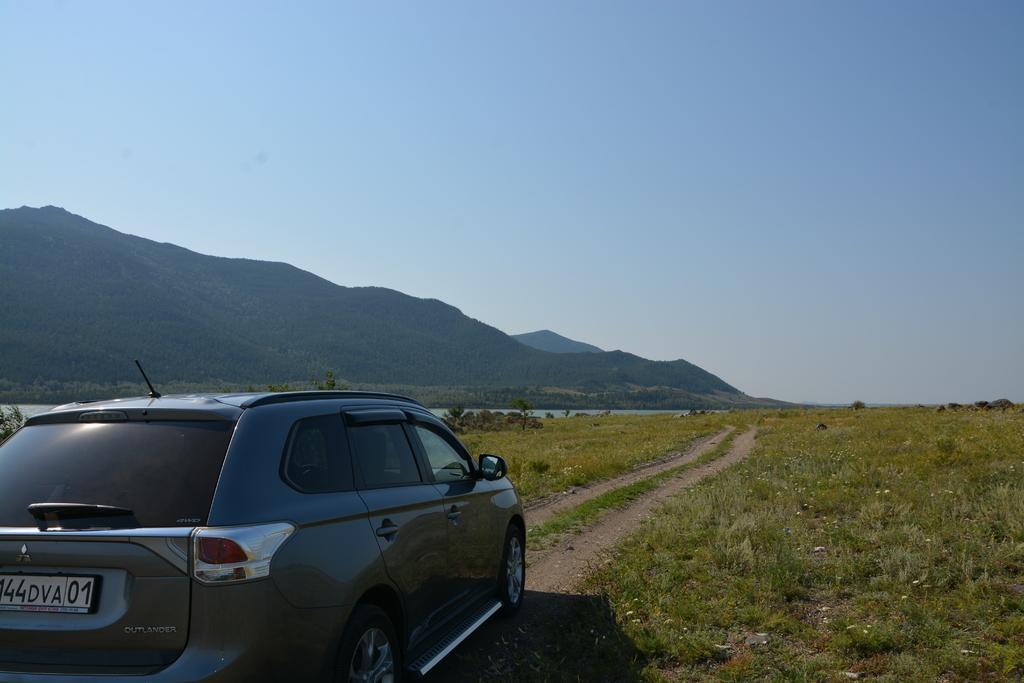How would you summarize this image in a sentence or two? In this image there is a car on the path, and in the background there are plants with flowers, grass, trees, water, hills,sky. 